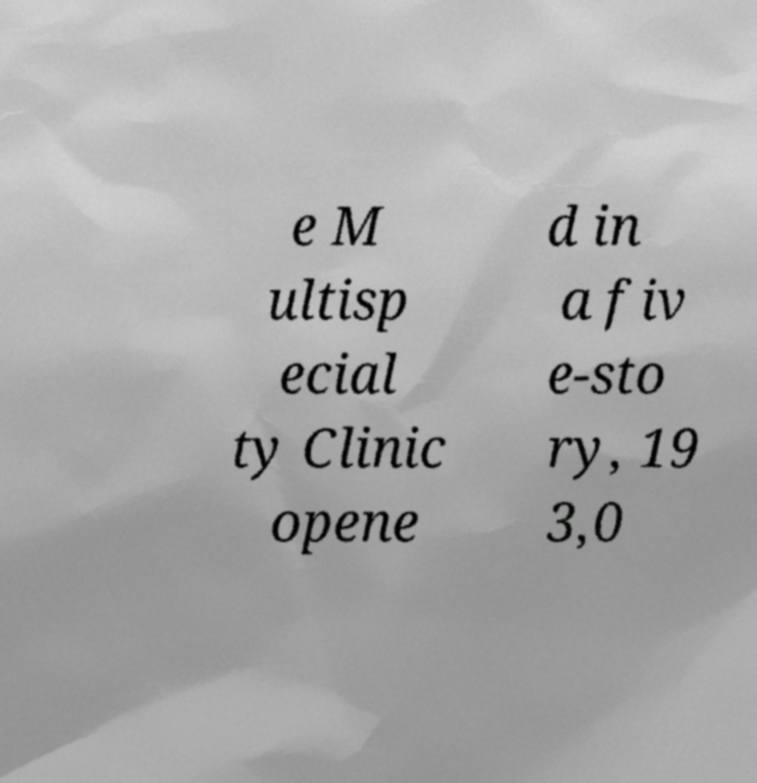For documentation purposes, I need the text within this image transcribed. Could you provide that? e M ultisp ecial ty Clinic opene d in a fiv e-sto ry, 19 3,0 